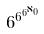Convert formula to latex. <formula><loc_0><loc_0><loc_500><loc_500>6 ^ { 6 ^ { 6 ^ { \aleph _ { 0 } } } }</formula> 